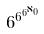Convert formula to latex. <formula><loc_0><loc_0><loc_500><loc_500>6 ^ { 6 ^ { 6 ^ { \aleph _ { 0 } } } }</formula> 